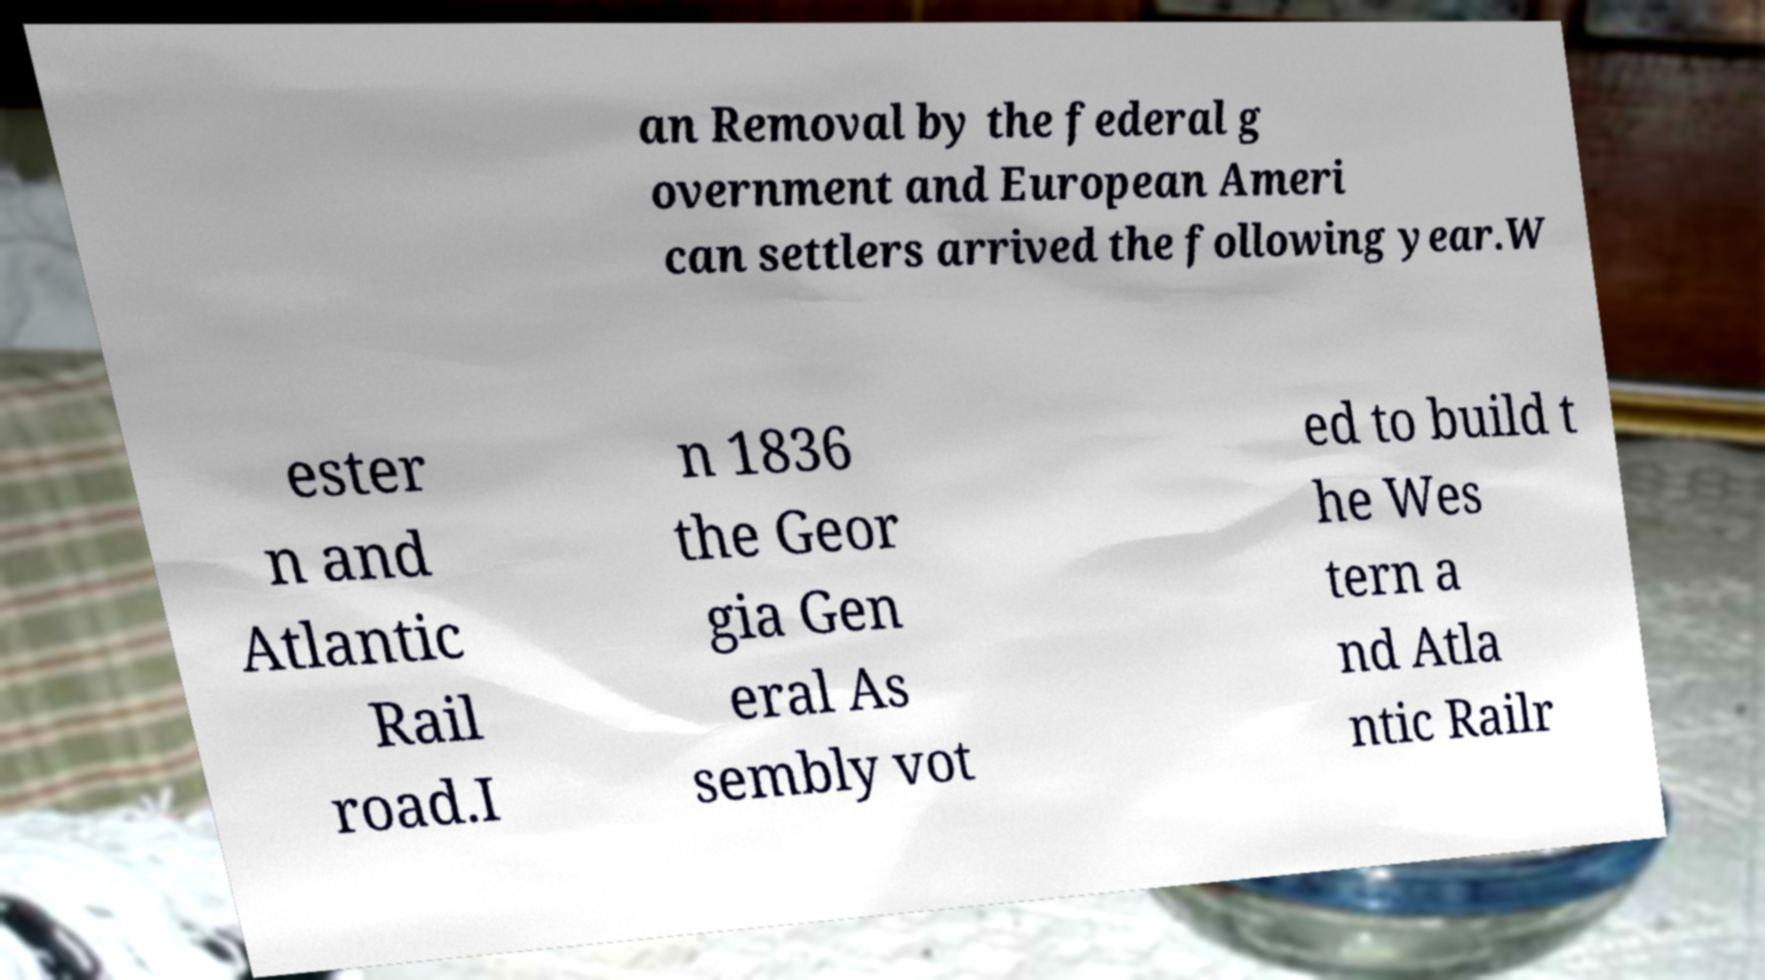Please read and relay the text visible in this image. What does it say? an Removal by the federal g overnment and European Ameri can settlers arrived the following year.W ester n and Atlantic Rail road.I n 1836 the Geor gia Gen eral As sembly vot ed to build t he Wes tern a nd Atla ntic Railr 